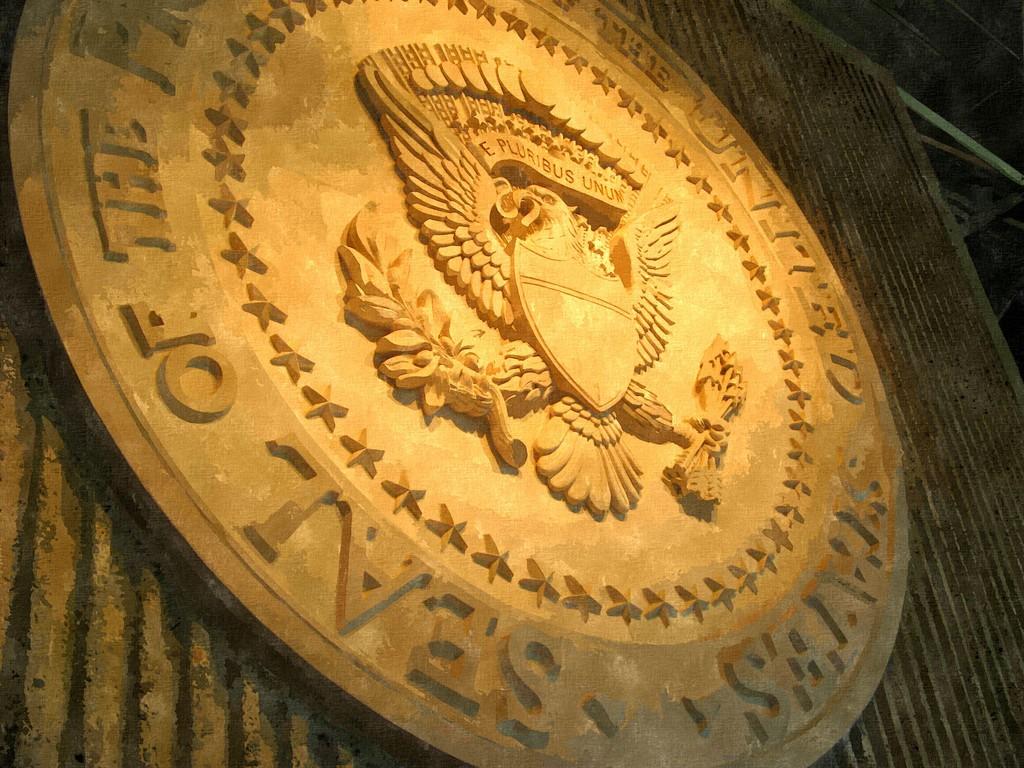This is the seal of what country?
Ensure brevity in your answer.  United states. 